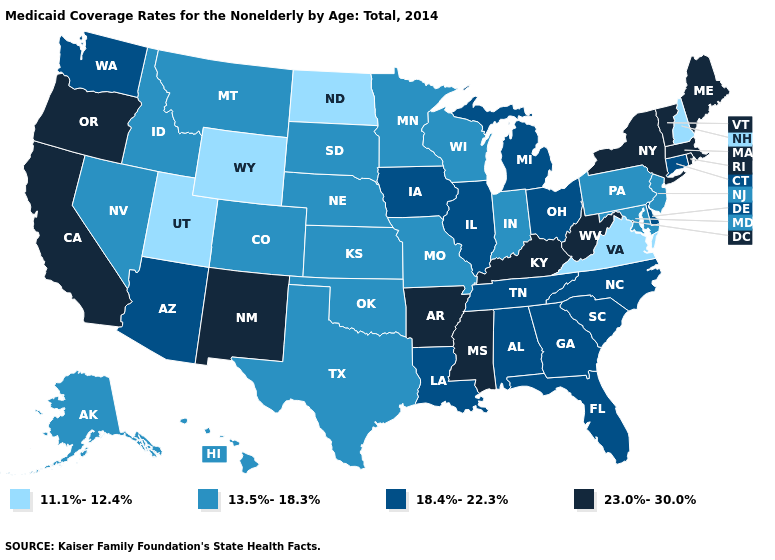Name the states that have a value in the range 18.4%-22.3%?
Quick response, please. Alabama, Arizona, Connecticut, Delaware, Florida, Georgia, Illinois, Iowa, Louisiana, Michigan, North Carolina, Ohio, South Carolina, Tennessee, Washington. What is the value of Iowa?
Short answer required. 18.4%-22.3%. Name the states that have a value in the range 23.0%-30.0%?
Answer briefly. Arkansas, California, Kentucky, Maine, Massachusetts, Mississippi, New Mexico, New York, Oregon, Rhode Island, Vermont, West Virginia. Does the first symbol in the legend represent the smallest category?
Answer briefly. Yes. Does Montana have a lower value than Ohio?
Write a very short answer. Yes. What is the value of Washington?
Be succinct. 18.4%-22.3%. Does the map have missing data?
Keep it brief. No. Among the states that border Minnesota , does Iowa have the highest value?
Quick response, please. Yes. Does South Dakota have the same value as Tennessee?
Concise answer only. No. What is the lowest value in the MidWest?
Answer briefly. 11.1%-12.4%. Does Wyoming have the lowest value in the West?
Answer briefly. Yes. What is the value of New Hampshire?
Quick response, please. 11.1%-12.4%. Among the states that border California , which have the highest value?
Give a very brief answer. Oregon. How many symbols are there in the legend?
Write a very short answer. 4. 